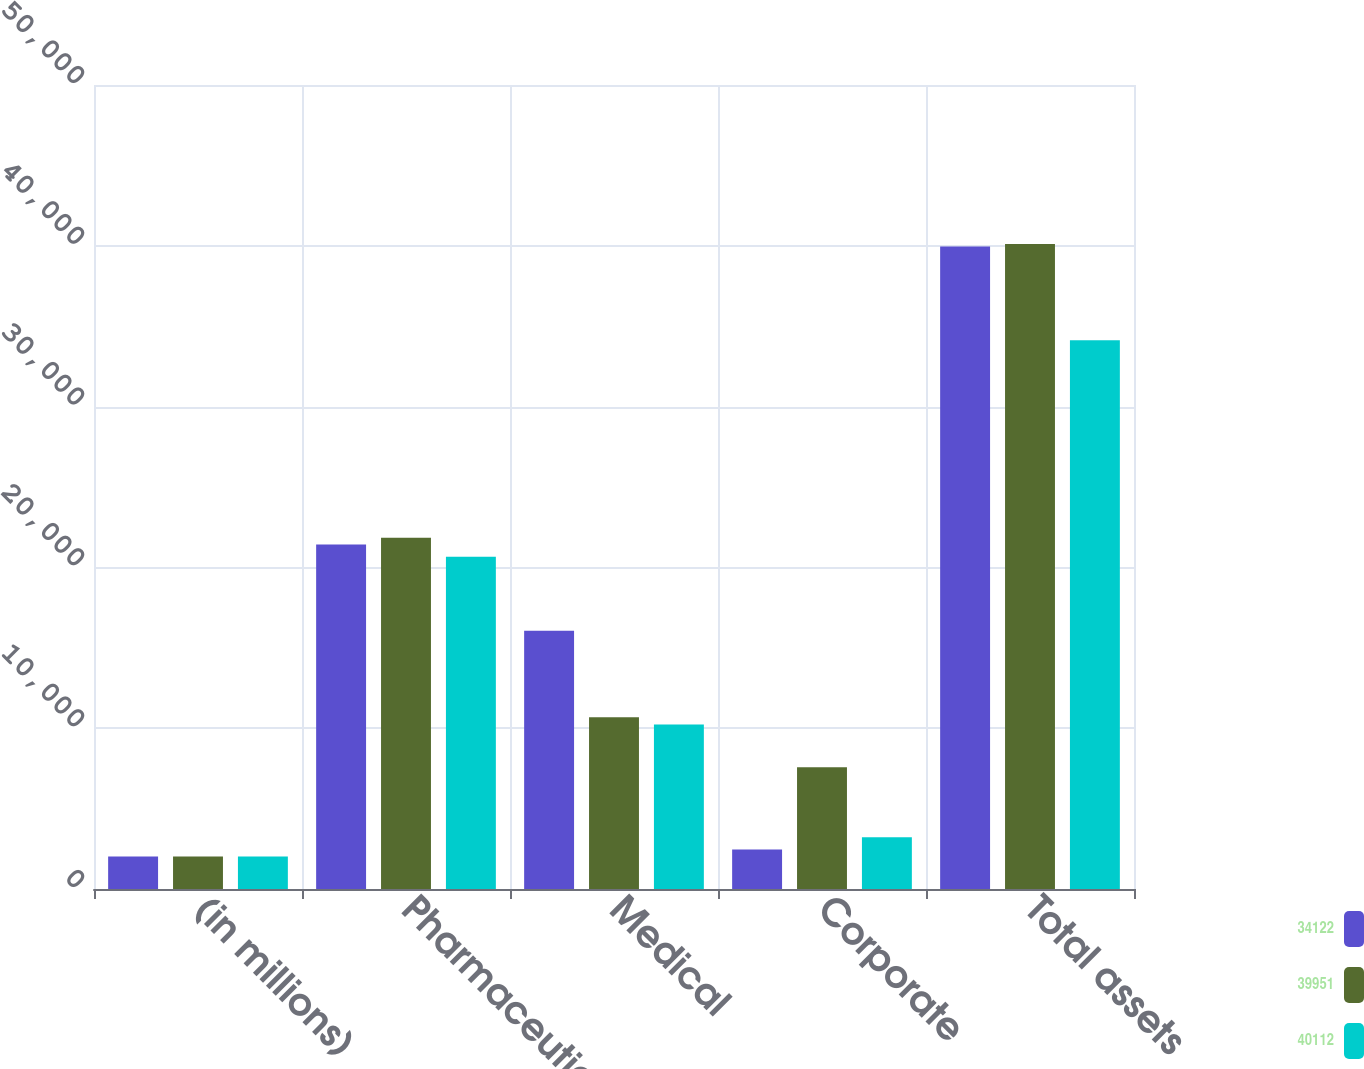Convert chart. <chart><loc_0><loc_0><loc_500><loc_500><stacked_bar_chart><ecel><fcel>(in millions)<fcel>Pharmaceutical<fcel>Medical<fcel>Corporate<fcel>Total assets<nl><fcel>34122<fcel>2018<fcel>21421<fcel>16066<fcel>2464<fcel>39951<nl><fcel>39951<fcel>2017<fcel>21848<fcel>10688<fcel>7576<fcel>40112<nl><fcel>40112<fcel>2016<fcel>20662<fcel>10236<fcel>3224<fcel>34122<nl></chart> 